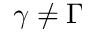<formula> <loc_0><loc_0><loc_500><loc_500>\gamma \neq \Gamma</formula> 